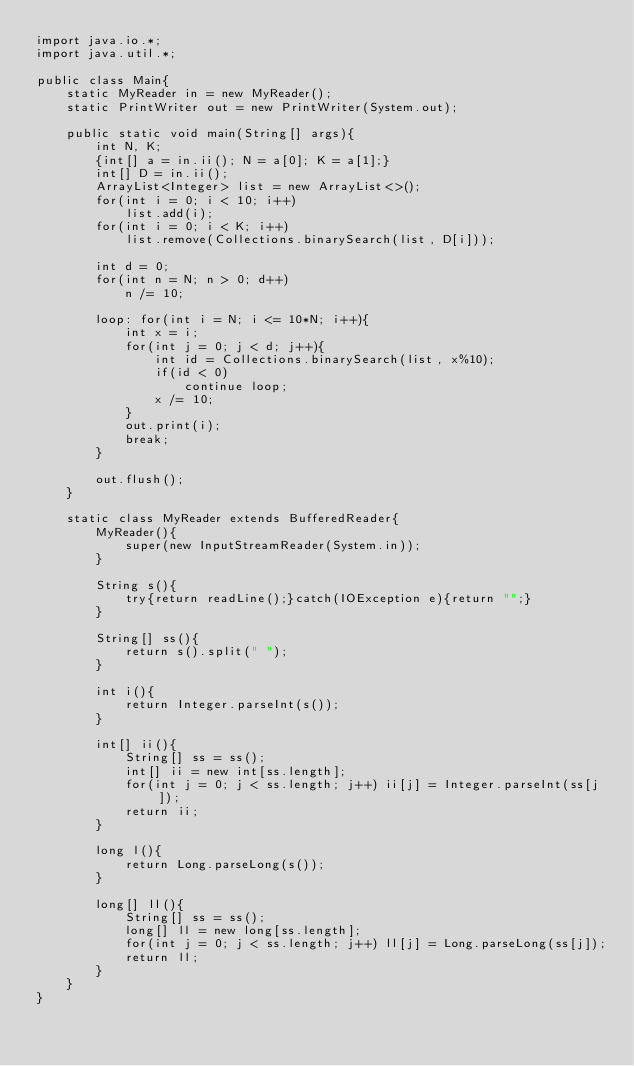Convert code to text. <code><loc_0><loc_0><loc_500><loc_500><_Java_>import java.io.*;
import java.util.*;

public class Main{
    static MyReader in = new MyReader();
    static PrintWriter out = new PrintWriter(System.out);

    public static void main(String[] args){
        int N, K;
        {int[] a = in.ii(); N = a[0]; K = a[1];}
        int[] D = in.ii();
        ArrayList<Integer> list = new ArrayList<>();
        for(int i = 0; i < 10; i++)
            list.add(i);
        for(int i = 0; i < K; i++)
            list.remove(Collections.binarySearch(list, D[i]));

        int d = 0;
        for(int n = N; n > 0; d++)
            n /= 10;

        loop: for(int i = N; i <= 10*N; i++){
            int x = i;
            for(int j = 0; j < d; j++){
                int id = Collections.binarySearch(list, x%10);
                if(id < 0)
                    continue loop;
                x /= 10;
            }
            out.print(i);
            break;
        }            
            
        out.flush();
    }

    static class MyReader extends BufferedReader{
        MyReader(){
            super(new InputStreamReader(System.in));
        }

        String s(){
            try{return readLine();}catch(IOException e){return "";}
        }

        String[] ss(){
            return s().split(" ");
        }

        int i(){
            return Integer.parseInt(s());
        }

        int[] ii(){
            String[] ss = ss();
            int[] ii = new int[ss.length];
            for(int j = 0; j < ss.length; j++) ii[j] = Integer.parseInt(ss[j]);
            return ii;
        }

        long l(){
            return Long.parseLong(s());
        }

        long[] ll(){
            String[] ss = ss();
            long[] ll = new long[ss.length];
            for(int j = 0; j < ss.length; j++) ll[j] = Long.parseLong(ss[j]);
            return ll;
        }
    }
}
</code> 